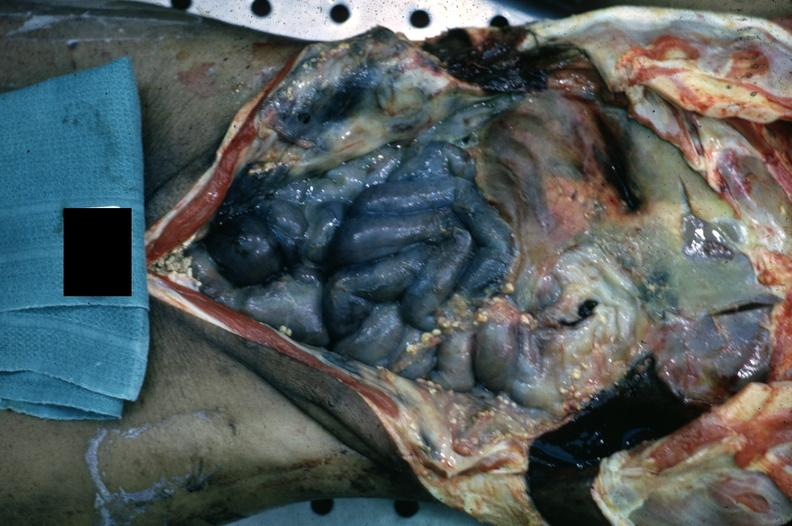s abdomen present?
Answer the question using a single word or phrase. Yes 